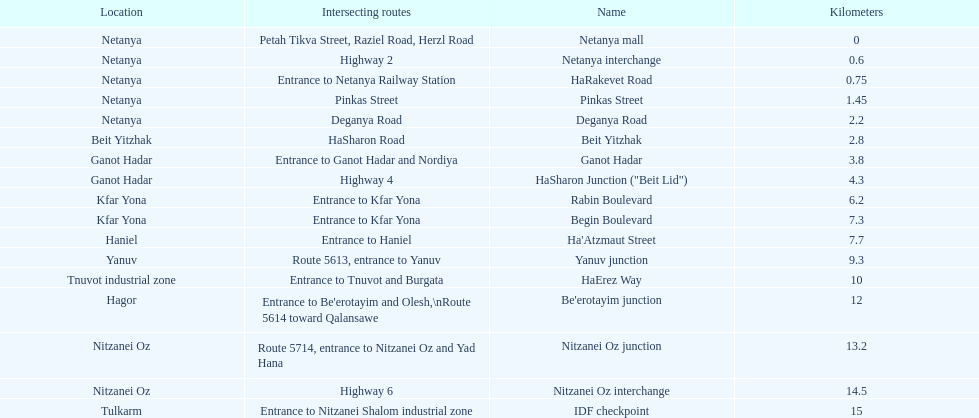After you complete deganya road, what portion comes next? Beit Yitzhak. 